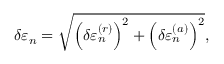<formula> <loc_0><loc_0><loc_500><loc_500>\delta \varepsilon _ { n } = \sqrt { \left ( \delta \varepsilon _ { n } ^ { ( r ) } \right ) ^ { 2 } + \left ( \delta \varepsilon _ { n } ^ { ( a ) } \right ) ^ { 2 } } ,</formula> 